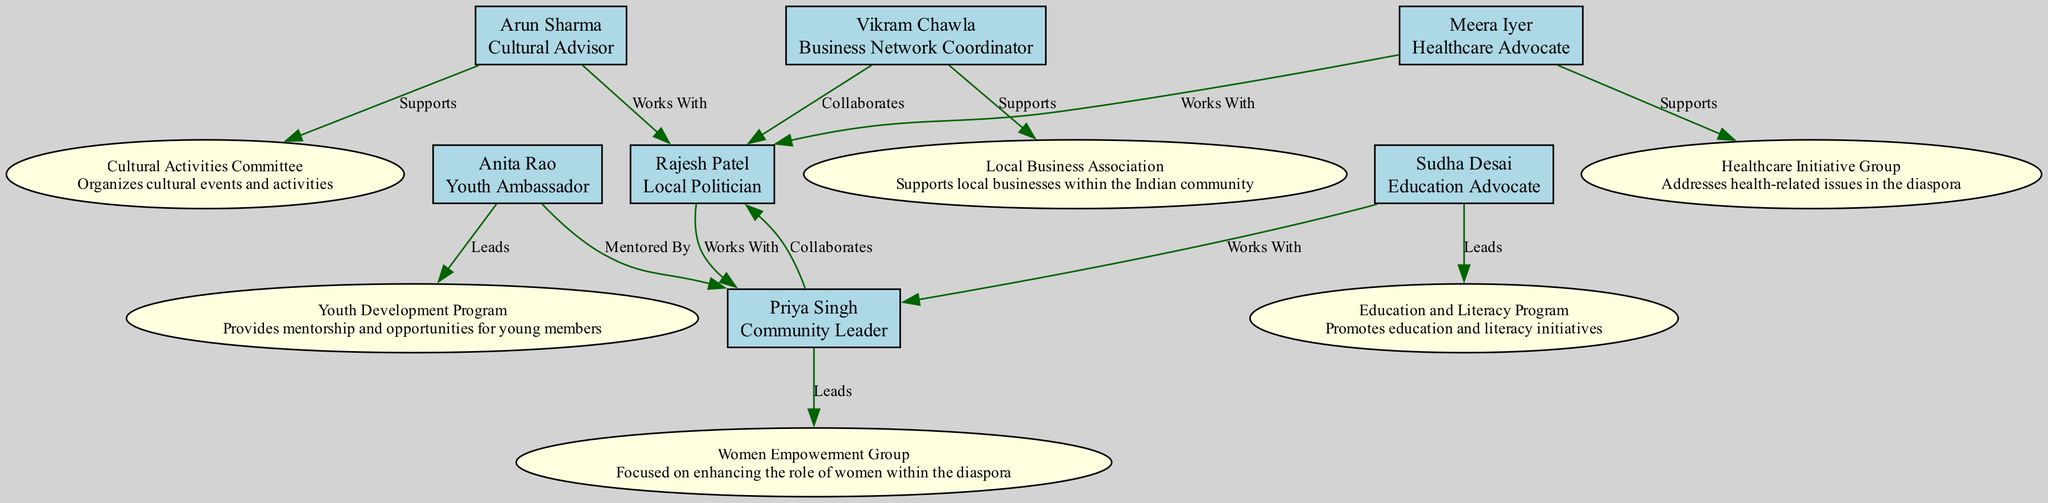What is the total number of members in the Indian Diaspora Support Network? Counting the nodes representing members in the diagram, there are 6 distinct individuals listed (Rajesh Patel, Priya Singh, Arun Sharma, Anita Rao, Meera Iyer, Vikram Chawla, and Sudha Desai).
Answer: 6 Who leads the Women Empowerment Group? Looking at the relationships outlined for the members, Priya Singh is specifically mentioned as leading the Women Empowerment Group.
Answer: Priya Singh Which member is mentored by Priya Singh? Reviewing Anita Rao's relationships, it is indicated that she is mentored by Priya Singh.
Answer: Anita Rao How many different subgroups are represented in the diagram? Examining the subgroup section, there are 6 distinct subgroups mentioned (Women Empowerment Group, Cultural Activities Committee, Youth Development Program, Healthcare Initiative Group, Local Business Association, Education and Literacy Program).
Answer: 6 Which member collaborates with both Rajesh Patel and Priya Singh? Analyzing the collaboration relationships, Vikram Chawla collaborates with Rajesh Patel and also supports the Local Business Association without a direct mention of Priya Singh, which means the answer focuses on the relationships with both key figures. This requires cross-referencing but leads us back to looking at direct relationships.
Answer: Vikram Chawla What is the primary role of Arun Sharma in the Indian Diaspora Support Network? The diagram states that Arun Sharma has the role of Cultural Advisor, which is explicitly labeled in his node description.
Answer: Cultural Advisor Which subgroup is associated with Meera Iyer? By examining the relationships of Meera Iyer, it indicates she supports the Healthcare Initiative Group directly as part of her role in the community, establishing her association clearly.
Answer: Healthcare Initiative Group How many collaborative relationships does Rajesh Patel have? Reviewing Rajesh Patel's connections, he works with Arun Sharma, collaborates with both Priya Singh and Vikram Chawla, giving him a total of 3 collaborative relationships listed in the diagram.
Answer: 3 Which group focuses on enhancing the role of women within the diaspora? From the description provided in the subgroup section, the Women Empowerment Group is specifically focused on enhancing the role of women within the diaspora community.
Answer: Women Empowerment Group 